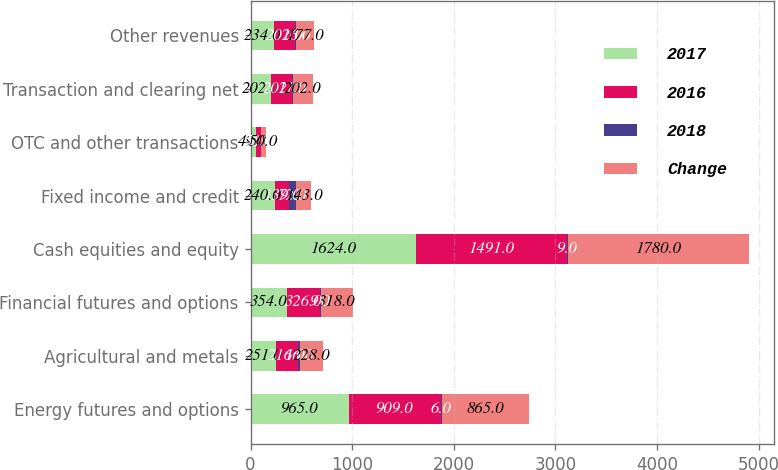Convert chart to OTSL. <chart><loc_0><loc_0><loc_500><loc_500><stacked_bar_chart><ecel><fcel>Energy futures and options<fcel>Agricultural and metals<fcel>Financial futures and options<fcel>Cash equities and equity<fcel>Fixed income and credit<fcel>OTC and other transactions<fcel>Transaction and clearing net<fcel>Other revenues<nl><fcel>2017<fcel>965<fcel>251<fcel>354<fcel>1624<fcel>240<fcel>49<fcel>202<fcel>234<nl><fcel>2016<fcel>909<fcel>216<fcel>326<fcel>1491<fcel>139<fcel>50<fcel>202<fcel>202<nl><fcel>2018<fcel>6<fcel>16<fcel>9<fcel>9<fcel>72<fcel>2<fcel>11<fcel>16<nl><fcel>Change<fcel>865<fcel>228<fcel>318<fcel>1780<fcel>143<fcel>50<fcel>202<fcel>177<nl></chart> 